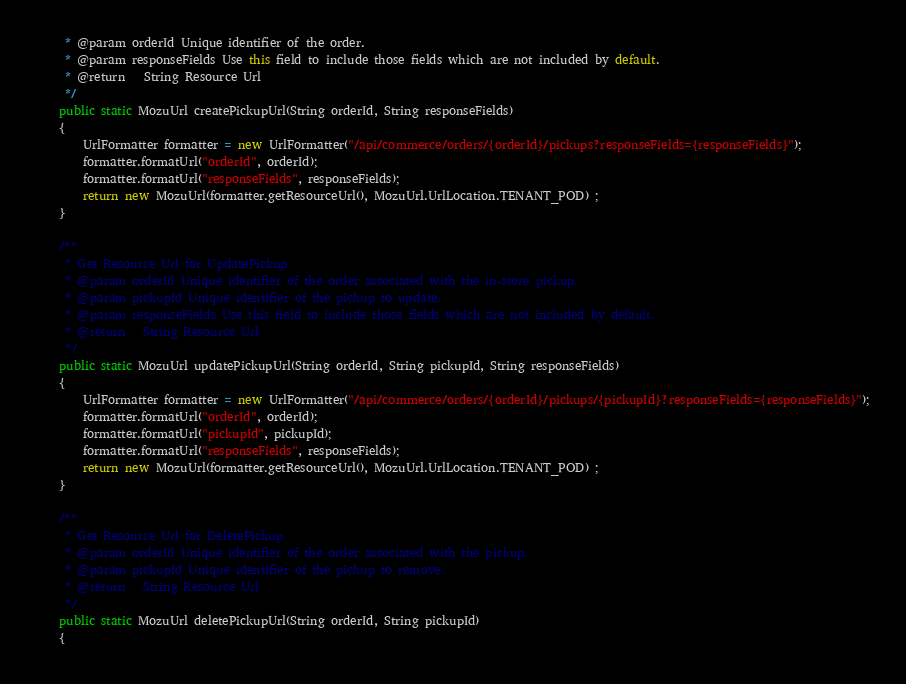Convert code to text. <code><loc_0><loc_0><loc_500><loc_500><_Java_>	 * @param orderId Unique identifier of the order.
	 * @param responseFields Use this field to include those fields which are not included by default.
	 * @return   String Resource Url
	 */
	public static MozuUrl createPickupUrl(String orderId, String responseFields)
	{
		UrlFormatter formatter = new UrlFormatter("/api/commerce/orders/{orderId}/pickups?responseFields={responseFields}");
		formatter.formatUrl("orderId", orderId);
		formatter.formatUrl("responseFields", responseFields);
		return new MozuUrl(formatter.getResourceUrl(), MozuUrl.UrlLocation.TENANT_POD) ;
	}

	/**
	 * Get Resource Url for UpdatePickup
	 * @param orderId Unique identifier of the order associated with the in-store pickup.
	 * @param pickupId Unique identifier of the pickup to update.
	 * @param responseFields Use this field to include those fields which are not included by default.
	 * @return   String Resource Url
	 */
	public static MozuUrl updatePickupUrl(String orderId, String pickupId, String responseFields)
	{
		UrlFormatter formatter = new UrlFormatter("/api/commerce/orders/{orderId}/pickups/{pickupId}?responseFields={responseFields}");
		formatter.formatUrl("orderId", orderId);
		formatter.formatUrl("pickupId", pickupId);
		formatter.formatUrl("responseFields", responseFields);
		return new MozuUrl(formatter.getResourceUrl(), MozuUrl.UrlLocation.TENANT_POD) ;
	}

	/**
	 * Get Resource Url for DeletePickup
	 * @param orderId Unique identifier of the order associated with the pickup.
	 * @param pickupId Unique identifier of the pickup to remove.
	 * @return   String Resource Url
	 */
	public static MozuUrl deletePickupUrl(String orderId, String pickupId)
	{</code> 